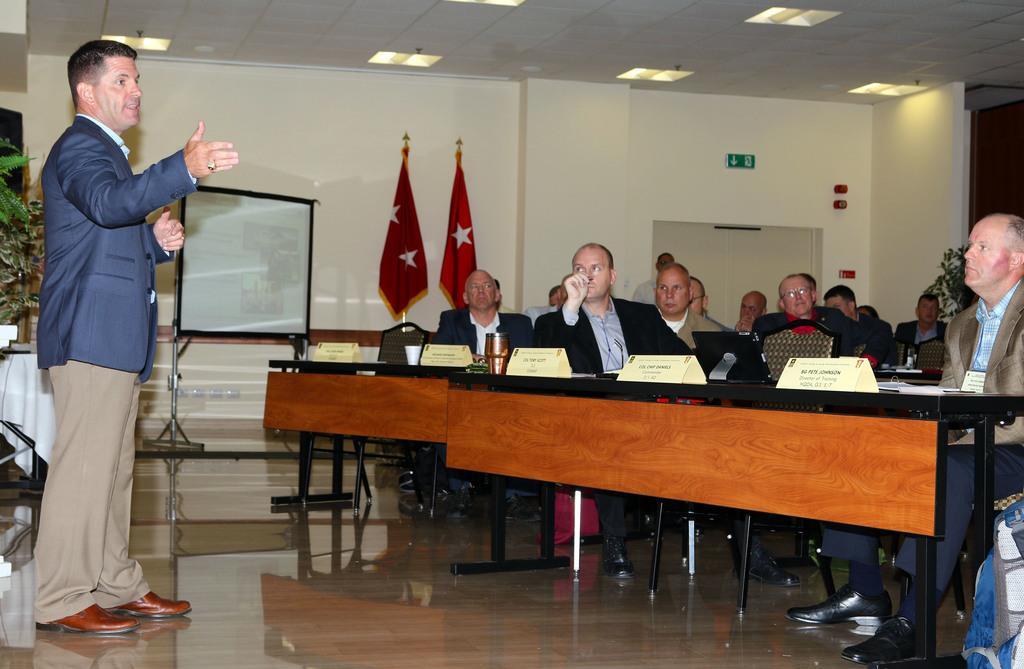Could you give a brief overview of what you see in this image? There is a person blue suit and cream pant talking to the people, at the back of this person there is a plant and at the right side of a picture there people sitting on the benches listening to opposite to them and at the back there is a projector. There are two flags in the middle there is a door at the back. 